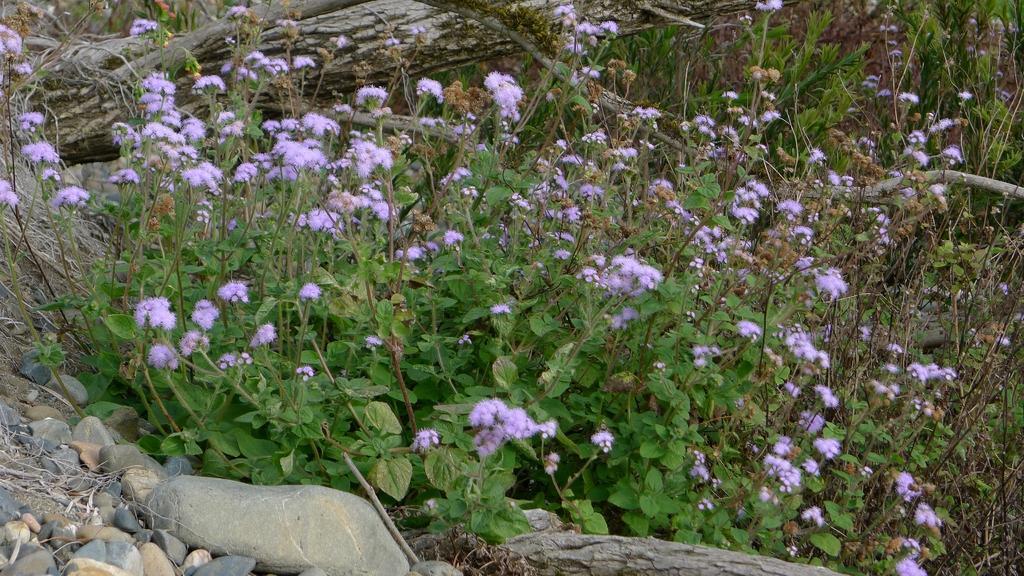How would you summarize this image in a sentence or two? In this image on the left I can see the stones. I can also see the flowers on the plants. 